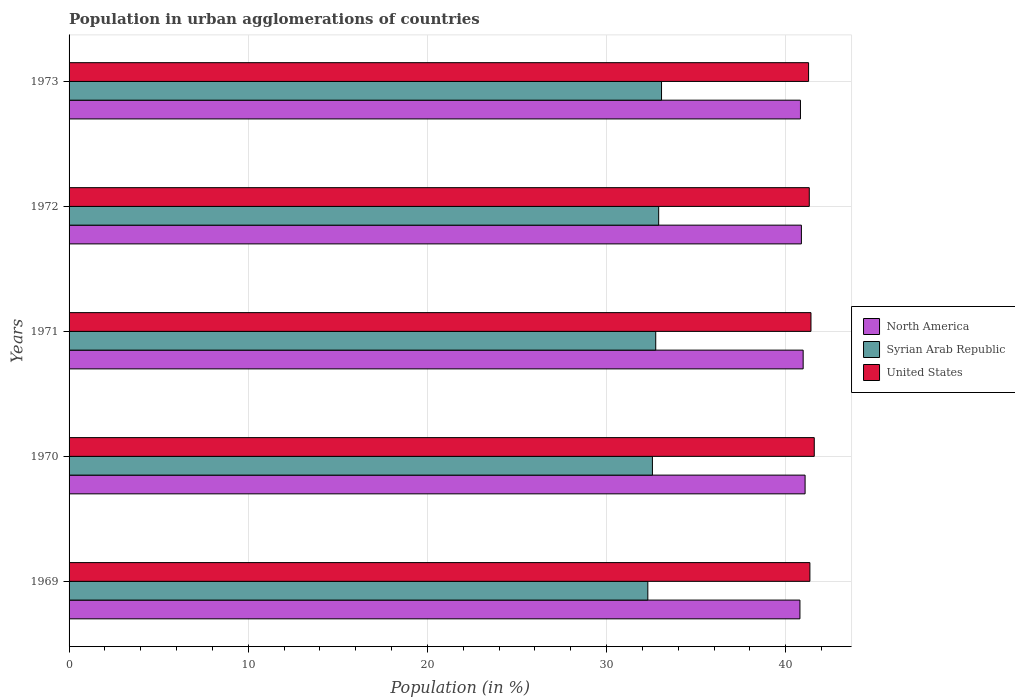How many groups of bars are there?
Offer a terse response. 5. How many bars are there on the 2nd tick from the bottom?
Ensure brevity in your answer.  3. What is the percentage of population in urban agglomerations in United States in 1973?
Make the answer very short. 41.28. Across all years, what is the maximum percentage of population in urban agglomerations in Syrian Arab Republic?
Your answer should be compact. 33.07. Across all years, what is the minimum percentage of population in urban agglomerations in United States?
Keep it short and to the point. 41.28. In which year was the percentage of population in urban agglomerations in North America minimum?
Your answer should be very brief. 1969. What is the total percentage of population in urban agglomerations in United States in the graph?
Ensure brevity in your answer.  206.95. What is the difference between the percentage of population in urban agglomerations in United States in 1969 and that in 1973?
Offer a terse response. 0.07. What is the difference between the percentage of population in urban agglomerations in Syrian Arab Republic in 1971 and the percentage of population in urban agglomerations in North America in 1969?
Give a very brief answer. -8.05. What is the average percentage of population in urban agglomerations in North America per year?
Your answer should be very brief. 40.91. In the year 1969, what is the difference between the percentage of population in urban agglomerations in United States and percentage of population in urban agglomerations in Syrian Arab Republic?
Offer a terse response. 9.05. What is the ratio of the percentage of population in urban agglomerations in United States in 1969 to that in 1971?
Keep it short and to the point. 1. Is the percentage of population in urban agglomerations in North America in 1969 less than that in 1972?
Provide a short and direct response. Yes. Is the difference between the percentage of population in urban agglomerations in United States in 1971 and 1972 greater than the difference between the percentage of population in urban agglomerations in Syrian Arab Republic in 1971 and 1972?
Your response must be concise. Yes. What is the difference between the highest and the second highest percentage of population in urban agglomerations in North America?
Give a very brief answer. 0.11. What is the difference between the highest and the lowest percentage of population in urban agglomerations in United States?
Provide a short and direct response. 0.32. In how many years, is the percentage of population in urban agglomerations in Syrian Arab Republic greater than the average percentage of population in urban agglomerations in Syrian Arab Republic taken over all years?
Make the answer very short. 3. What does the 2nd bar from the top in 1970 represents?
Offer a very short reply. Syrian Arab Republic. What does the 2nd bar from the bottom in 1970 represents?
Provide a succinct answer. Syrian Arab Republic. How many years are there in the graph?
Make the answer very short. 5. What is the difference between two consecutive major ticks on the X-axis?
Give a very brief answer. 10. Where does the legend appear in the graph?
Provide a short and direct response. Center right. How many legend labels are there?
Offer a terse response. 3. What is the title of the graph?
Provide a succinct answer. Population in urban agglomerations of countries. Does "Morocco" appear as one of the legend labels in the graph?
Offer a very short reply. No. What is the label or title of the Y-axis?
Give a very brief answer. Years. What is the Population (in %) in North America in 1969?
Provide a short and direct response. 40.79. What is the Population (in %) in Syrian Arab Republic in 1969?
Your response must be concise. 32.3. What is the Population (in %) in United States in 1969?
Keep it short and to the point. 41.35. What is the Population (in %) of North America in 1970?
Ensure brevity in your answer.  41.08. What is the Population (in %) in Syrian Arab Republic in 1970?
Your answer should be compact. 32.56. What is the Population (in %) of United States in 1970?
Provide a succinct answer. 41.59. What is the Population (in %) of North America in 1971?
Ensure brevity in your answer.  40.97. What is the Population (in %) of Syrian Arab Republic in 1971?
Provide a succinct answer. 32.75. What is the Population (in %) of United States in 1971?
Give a very brief answer. 41.41. What is the Population (in %) in North America in 1972?
Your response must be concise. 40.88. What is the Population (in %) in Syrian Arab Republic in 1972?
Make the answer very short. 32.91. What is the Population (in %) of United States in 1972?
Offer a terse response. 41.32. What is the Population (in %) in North America in 1973?
Your answer should be very brief. 40.82. What is the Population (in %) of Syrian Arab Republic in 1973?
Give a very brief answer. 33.07. What is the Population (in %) of United States in 1973?
Offer a very short reply. 41.28. Across all years, what is the maximum Population (in %) in North America?
Provide a succinct answer. 41.08. Across all years, what is the maximum Population (in %) of Syrian Arab Republic?
Your answer should be compact. 33.07. Across all years, what is the maximum Population (in %) of United States?
Your response must be concise. 41.59. Across all years, what is the minimum Population (in %) in North America?
Keep it short and to the point. 40.79. Across all years, what is the minimum Population (in %) in Syrian Arab Republic?
Give a very brief answer. 32.3. Across all years, what is the minimum Population (in %) in United States?
Your answer should be very brief. 41.28. What is the total Population (in %) in North America in the graph?
Keep it short and to the point. 204.55. What is the total Population (in %) in Syrian Arab Republic in the graph?
Ensure brevity in your answer.  163.59. What is the total Population (in %) of United States in the graph?
Your answer should be very brief. 206.95. What is the difference between the Population (in %) in North America in 1969 and that in 1970?
Offer a very short reply. -0.29. What is the difference between the Population (in %) in Syrian Arab Republic in 1969 and that in 1970?
Ensure brevity in your answer.  -0.26. What is the difference between the Population (in %) of United States in 1969 and that in 1970?
Ensure brevity in your answer.  -0.24. What is the difference between the Population (in %) of North America in 1969 and that in 1971?
Offer a terse response. -0.18. What is the difference between the Population (in %) of Syrian Arab Republic in 1969 and that in 1971?
Provide a succinct answer. -0.44. What is the difference between the Population (in %) in United States in 1969 and that in 1971?
Ensure brevity in your answer.  -0.06. What is the difference between the Population (in %) of North America in 1969 and that in 1972?
Offer a very short reply. -0.08. What is the difference between the Population (in %) in Syrian Arab Republic in 1969 and that in 1972?
Provide a short and direct response. -0.6. What is the difference between the Population (in %) of United States in 1969 and that in 1972?
Keep it short and to the point. 0.03. What is the difference between the Population (in %) of North America in 1969 and that in 1973?
Your response must be concise. -0.03. What is the difference between the Population (in %) of Syrian Arab Republic in 1969 and that in 1973?
Your response must be concise. -0.76. What is the difference between the Population (in %) in United States in 1969 and that in 1973?
Offer a very short reply. 0.07. What is the difference between the Population (in %) of North America in 1970 and that in 1971?
Your answer should be very brief. 0.11. What is the difference between the Population (in %) in Syrian Arab Republic in 1970 and that in 1971?
Offer a very short reply. -0.19. What is the difference between the Population (in %) in United States in 1970 and that in 1971?
Offer a terse response. 0.18. What is the difference between the Population (in %) in North America in 1970 and that in 1972?
Offer a terse response. 0.21. What is the difference between the Population (in %) in Syrian Arab Republic in 1970 and that in 1972?
Offer a very short reply. -0.35. What is the difference between the Population (in %) in United States in 1970 and that in 1972?
Ensure brevity in your answer.  0.28. What is the difference between the Population (in %) in North America in 1970 and that in 1973?
Offer a very short reply. 0.26. What is the difference between the Population (in %) of Syrian Arab Republic in 1970 and that in 1973?
Your response must be concise. -0.51. What is the difference between the Population (in %) in United States in 1970 and that in 1973?
Provide a succinct answer. 0.32. What is the difference between the Population (in %) of North America in 1971 and that in 1972?
Provide a succinct answer. 0.1. What is the difference between the Population (in %) in Syrian Arab Republic in 1971 and that in 1972?
Provide a succinct answer. -0.16. What is the difference between the Population (in %) of United States in 1971 and that in 1972?
Make the answer very short. 0.09. What is the difference between the Population (in %) of North America in 1971 and that in 1973?
Offer a very short reply. 0.15. What is the difference between the Population (in %) of Syrian Arab Republic in 1971 and that in 1973?
Give a very brief answer. -0.32. What is the difference between the Population (in %) of United States in 1971 and that in 1973?
Provide a short and direct response. 0.13. What is the difference between the Population (in %) of North America in 1972 and that in 1973?
Offer a terse response. 0.05. What is the difference between the Population (in %) in Syrian Arab Republic in 1972 and that in 1973?
Your response must be concise. -0.16. What is the difference between the Population (in %) of United States in 1972 and that in 1973?
Give a very brief answer. 0.04. What is the difference between the Population (in %) in North America in 1969 and the Population (in %) in Syrian Arab Republic in 1970?
Give a very brief answer. 8.23. What is the difference between the Population (in %) in North America in 1969 and the Population (in %) in United States in 1970?
Offer a very short reply. -0.8. What is the difference between the Population (in %) of Syrian Arab Republic in 1969 and the Population (in %) of United States in 1970?
Your answer should be compact. -9.29. What is the difference between the Population (in %) of North America in 1969 and the Population (in %) of Syrian Arab Republic in 1971?
Provide a short and direct response. 8.05. What is the difference between the Population (in %) in North America in 1969 and the Population (in %) in United States in 1971?
Give a very brief answer. -0.62. What is the difference between the Population (in %) in Syrian Arab Republic in 1969 and the Population (in %) in United States in 1971?
Provide a short and direct response. -9.11. What is the difference between the Population (in %) in North America in 1969 and the Population (in %) in Syrian Arab Republic in 1972?
Offer a very short reply. 7.89. What is the difference between the Population (in %) of North America in 1969 and the Population (in %) of United States in 1972?
Offer a very short reply. -0.52. What is the difference between the Population (in %) in Syrian Arab Republic in 1969 and the Population (in %) in United States in 1972?
Ensure brevity in your answer.  -9.01. What is the difference between the Population (in %) of North America in 1969 and the Population (in %) of Syrian Arab Republic in 1973?
Provide a succinct answer. 7.73. What is the difference between the Population (in %) of North America in 1969 and the Population (in %) of United States in 1973?
Provide a succinct answer. -0.48. What is the difference between the Population (in %) of Syrian Arab Republic in 1969 and the Population (in %) of United States in 1973?
Provide a short and direct response. -8.97. What is the difference between the Population (in %) in North America in 1970 and the Population (in %) in Syrian Arab Republic in 1971?
Your answer should be very brief. 8.34. What is the difference between the Population (in %) of North America in 1970 and the Population (in %) of United States in 1971?
Provide a short and direct response. -0.33. What is the difference between the Population (in %) of Syrian Arab Republic in 1970 and the Population (in %) of United States in 1971?
Give a very brief answer. -8.85. What is the difference between the Population (in %) in North America in 1970 and the Population (in %) in Syrian Arab Republic in 1972?
Your response must be concise. 8.17. What is the difference between the Population (in %) in North America in 1970 and the Population (in %) in United States in 1972?
Give a very brief answer. -0.23. What is the difference between the Population (in %) in Syrian Arab Republic in 1970 and the Population (in %) in United States in 1972?
Provide a short and direct response. -8.76. What is the difference between the Population (in %) in North America in 1970 and the Population (in %) in Syrian Arab Republic in 1973?
Offer a very short reply. 8.01. What is the difference between the Population (in %) of North America in 1970 and the Population (in %) of United States in 1973?
Keep it short and to the point. -0.19. What is the difference between the Population (in %) of Syrian Arab Republic in 1970 and the Population (in %) of United States in 1973?
Your response must be concise. -8.72. What is the difference between the Population (in %) of North America in 1971 and the Population (in %) of Syrian Arab Republic in 1972?
Provide a short and direct response. 8.06. What is the difference between the Population (in %) of North America in 1971 and the Population (in %) of United States in 1972?
Your response must be concise. -0.34. What is the difference between the Population (in %) of Syrian Arab Republic in 1971 and the Population (in %) of United States in 1972?
Offer a very short reply. -8.57. What is the difference between the Population (in %) in North America in 1971 and the Population (in %) in Syrian Arab Republic in 1973?
Provide a succinct answer. 7.91. What is the difference between the Population (in %) of North America in 1971 and the Population (in %) of United States in 1973?
Provide a short and direct response. -0.3. What is the difference between the Population (in %) in Syrian Arab Republic in 1971 and the Population (in %) in United States in 1973?
Offer a terse response. -8.53. What is the difference between the Population (in %) in North America in 1972 and the Population (in %) in Syrian Arab Republic in 1973?
Make the answer very short. 7.81. What is the difference between the Population (in %) in North America in 1972 and the Population (in %) in United States in 1973?
Ensure brevity in your answer.  -0.4. What is the difference between the Population (in %) in Syrian Arab Republic in 1972 and the Population (in %) in United States in 1973?
Your answer should be compact. -8.37. What is the average Population (in %) in North America per year?
Your response must be concise. 40.91. What is the average Population (in %) in Syrian Arab Republic per year?
Make the answer very short. 32.72. What is the average Population (in %) in United States per year?
Give a very brief answer. 41.39. In the year 1969, what is the difference between the Population (in %) of North America and Population (in %) of Syrian Arab Republic?
Offer a very short reply. 8.49. In the year 1969, what is the difference between the Population (in %) of North America and Population (in %) of United States?
Offer a terse response. -0.56. In the year 1969, what is the difference between the Population (in %) in Syrian Arab Republic and Population (in %) in United States?
Make the answer very short. -9.05. In the year 1970, what is the difference between the Population (in %) of North America and Population (in %) of Syrian Arab Republic?
Your answer should be very brief. 8.52. In the year 1970, what is the difference between the Population (in %) in North America and Population (in %) in United States?
Ensure brevity in your answer.  -0.51. In the year 1970, what is the difference between the Population (in %) in Syrian Arab Republic and Population (in %) in United States?
Offer a very short reply. -9.03. In the year 1971, what is the difference between the Population (in %) in North America and Population (in %) in Syrian Arab Republic?
Provide a short and direct response. 8.23. In the year 1971, what is the difference between the Population (in %) in North America and Population (in %) in United States?
Provide a short and direct response. -0.44. In the year 1971, what is the difference between the Population (in %) of Syrian Arab Republic and Population (in %) of United States?
Your answer should be compact. -8.66. In the year 1972, what is the difference between the Population (in %) of North America and Population (in %) of Syrian Arab Republic?
Offer a terse response. 7.97. In the year 1972, what is the difference between the Population (in %) in North America and Population (in %) in United States?
Provide a short and direct response. -0.44. In the year 1972, what is the difference between the Population (in %) in Syrian Arab Republic and Population (in %) in United States?
Give a very brief answer. -8.41. In the year 1973, what is the difference between the Population (in %) in North America and Population (in %) in Syrian Arab Republic?
Provide a short and direct response. 7.75. In the year 1973, what is the difference between the Population (in %) of North America and Population (in %) of United States?
Provide a short and direct response. -0.45. In the year 1973, what is the difference between the Population (in %) of Syrian Arab Republic and Population (in %) of United States?
Your answer should be compact. -8.21. What is the ratio of the Population (in %) of North America in 1969 to that in 1970?
Your answer should be compact. 0.99. What is the ratio of the Population (in %) in North America in 1969 to that in 1971?
Keep it short and to the point. 1. What is the ratio of the Population (in %) in Syrian Arab Republic in 1969 to that in 1971?
Your answer should be very brief. 0.99. What is the ratio of the Population (in %) of Syrian Arab Republic in 1969 to that in 1972?
Provide a short and direct response. 0.98. What is the ratio of the Population (in %) of Syrian Arab Republic in 1969 to that in 1973?
Give a very brief answer. 0.98. What is the ratio of the Population (in %) of North America in 1970 to that in 1971?
Provide a short and direct response. 1. What is the ratio of the Population (in %) of Syrian Arab Republic in 1970 to that in 1971?
Offer a terse response. 0.99. What is the ratio of the Population (in %) of North America in 1970 to that in 1972?
Provide a succinct answer. 1. What is the ratio of the Population (in %) in Syrian Arab Republic in 1970 to that in 1972?
Give a very brief answer. 0.99. What is the ratio of the Population (in %) in United States in 1970 to that in 1972?
Your response must be concise. 1.01. What is the ratio of the Population (in %) of Syrian Arab Republic in 1970 to that in 1973?
Your answer should be compact. 0.98. What is the ratio of the Population (in %) in United States in 1970 to that in 1973?
Offer a terse response. 1.01. What is the ratio of the Population (in %) of Syrian Arab Republic in 1971 to that in 1973?
Your answer should be very brief. 0.99. What is the ratio of the Population (in %) in United States in 1971 to that in 1973?
Give a very brief answer. 1. What is the ratio of the Population (in %) of North America in 1972 to that in 1973?
Keep it short and to the point. 1. What is the ratio of the Population (in %) in United States in 1972 to that in 1973?
Your response must be concise. 1. What is the difference between the highest and the second highest Population (in %) of North America?
Your response must be concise. 0.11. What is the difference between the highest and the second highest Population (in %) of Syrian Arab Republic?
Keep it short and to the point. 0.16. What is the difference between the highest and the second highest Population (in %) in United States?
Your response must be concise. 0.18. What is the difference between the highest and the lowest Population (in %) in North America?
Offer a very short reply. 0.29. What is the difference between the highest and the lowest Population (in %) of Syrian Arab Republic?
Keep it short and to the point. 0.76. What is the difference between the highest and the lowest Population (in %) in United States?
Your answer should be very brief. 0.32. 